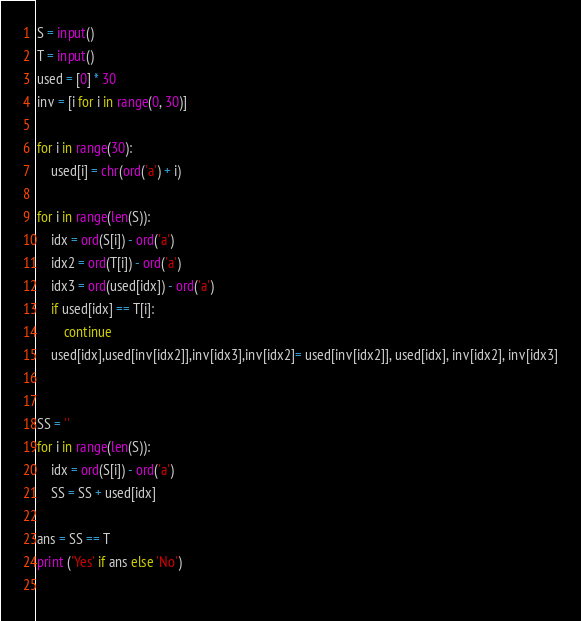<code> <loc_0><loc_0><loc_500><loc_500><_Python_>S = input()
T = input()
used = [0] * 30
inv = [i for i in range(0, 30)]

for i in range(30):
    used[i] = chr(ord('a') + i)

for i in range(len(S)):
    idx = ord(S[i]) - ord('a')
    idx2 = ord(T[i]) - ord('a')
    idx3 = ord(used[idx]) - ord('a')
    if used[idx] == T[i]:
        continue
    used[idx],used[inv[idx2]],inv[idx3],inv[idx2]= used[inv[idx2]], used[idx], inv[idx2], inv[idx3]


SS = ''
for i in range(len(S)):
    idx = ord(S[i]) - ord('a')
    SS = SS + used[idx]

ans = SS == T
print ('Yes' if ans else 'No')
    
</code> 